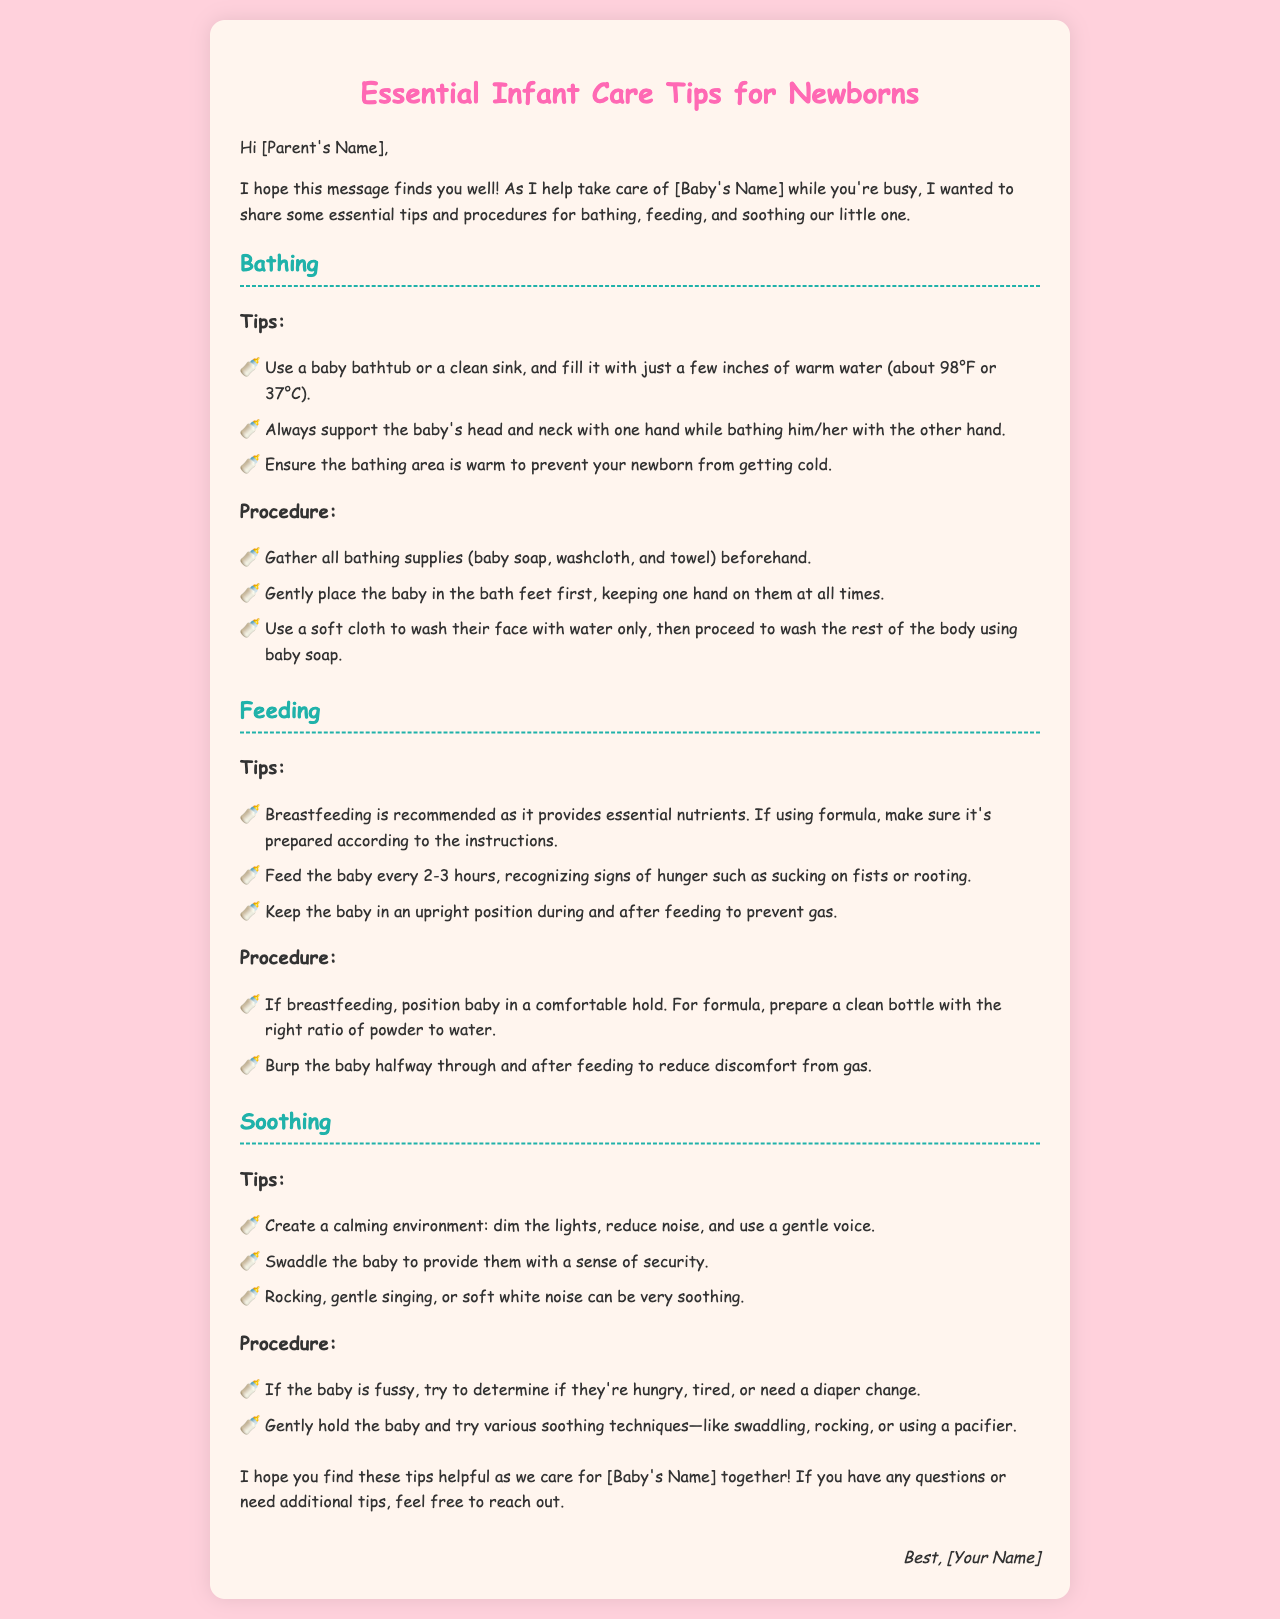What is the recommended water temperature for bathing? The recommended water temperature for bathing the baby is about 98°F or 37°C.
Answer: 98°F or 37°C How should a baby be supported during a bath? The document states that the baby's head and neck should be supported with one hand while bathing them with the other hand.
Answer: One hand How often should the baby be fed? According to the document, the baby should be fed every 2-3 hours.
Answer: Every 2-3 hours What is one sign of hunger in a newborn? The document mentions that sucking on fists is a sign of hunger in a newborn.
Answer: Sucking on fists What are two soothing techniques mentioned in the document? The document lists swaddling and rocking as soothing techniques for the baby.
Answer: Swaddling and rocking What should you do if a baby is fussy? The document suggests determining if the baby is hungry, tired, or needs a diaper change if they are fussy.
Answer: Determine needs Which color is used for the document's heading? The color used for the heading in the document is pink (#FF69B4).
Answer: Pink What should be prepared beforehand for bathing? The document advises gathering all bathing supplies such as baby soap, washcloth, and towel beforehand.
Answer: Bathing supplies What is the purpose of dimming the lights? Dimming the lights is recommended to create a calming environment for the baby.
Answer: Calming environment 